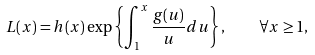Convert formula to latex. <formula><loc_0><loc_0><loc_500><loc_500>L ( x ) = h ( x ) \exp \left \{ \int _ { 1 } ^ { x } \frac { g ( u ) } { u } d u \right \} , \quad \forall x \geq 1 ,</formula> 